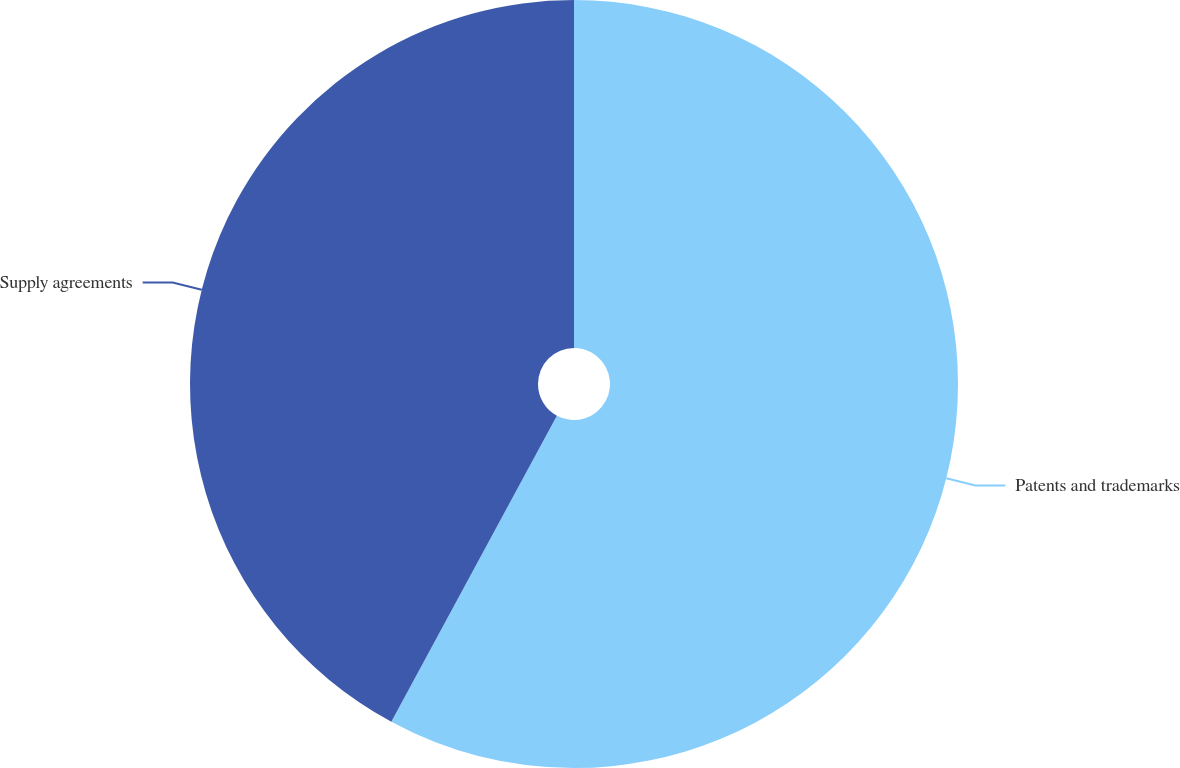<chart> <loc_0><loc_0><loc_500><loc_500><pie_chart><fcel>Patents and trademarks<fcel>Supply agreements<nl><fcel>57.89%<fcel>42.11%<nl></chart> 